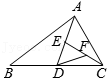What geometrical significance might points D, E, and F hold in the context of triangle ABC? Points D, E, and F likely represent significant geometrical features such as midpoints or section points. If these points divide the sides in specific ratios, they could be useful in applying theorems like Menelaus' theorem for transversals or Ceva's theorem to explore collinearities or concurrencies within the triangle. 